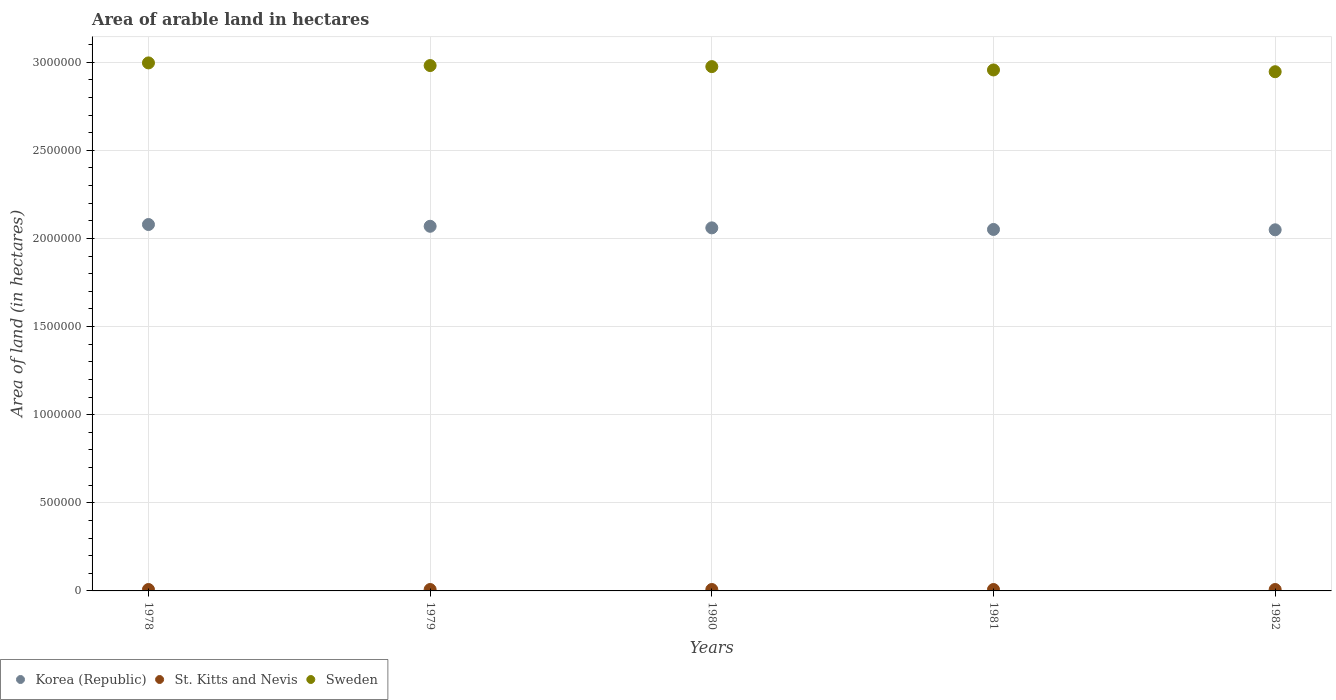What is the total arable land in Sweden in 1979?
Your response must be concise. 2.98e+06. Across all years, what is the maximum total arable land in St. Kitts and Nevis?
Your answer should be compact. 8000. Across all years, what is the minimum total arable land in Sweden?
Your response must be concise. 2.95e+06. In which year was the total arable land in Sweden maximum?
Ensure brevity in your answer.  1978. In which year was the total arable land in Korea (Republic) minimum?
Your answer should be compact. 1982. What is the total total arable land in St. Kitts and Nevis in the graph?
Provide a succinct answer. 4.00e+04. What is the difference between the total arable land in Korea (Republic) in 1978 and the total arable land in Sweden in 1980?
Provide a short and direct response. -8.96e+05. What is the average total arable land in Korea (Republic) per year?
Make the answer very short. 2.06e+06. In the year 1979, what is the difference between the total arable land in St. Kitts and Nevis and total arable land in Sweden?
Provide a short and direct response. -2.97e+06. In how many years, is the total arable land in Korea (Republic) greater than 2100000 hectares?
Keep it short and to the point. 0. Is the total arable land in St. Kitts and Nevis in 1981 less than that in 1982?
Your answer should be very brief. No. What is the difference between the highest and the second highest total arable land in Korea (Republic)?
Give a very brief answer. 10000. What is the difference between the highest and the lowest total arable land in Sweden?
Keep it short and to the point. 5.00e+04. In how many years, is the total arable land in Korea (Republic) greater than the average total arable land in Korea (Republic) taken over all years?
Your answer should be very brief. 2. Is it the case that in every year, the sum of the total arable land in Sweden and total arable land in Korea (Republic)  is greater than the total arable land in St. Kitts and Nevis?
Provide a short and direct response. Yes. How many dotlines are there?
Your answer should be very brief. 3. What is the difference between two consecutive major ticks on the Y-axis?
Offer a very short reply. 5.00e+05. Does the graph contain any zero values?
Give a very brief answer. No. How are the legend labels stacked?
Give a very brief answer. Horizontal. What is the title of the graph?
Provide a short and direct response. Area of arable land in hectares. What is the label or title of the Y-axis?
Make the answer very short. Area of land (in hectares). What is the Area of land (in hectares) of Korea (Republic) in 1978?
Ensure brevity in your answer.  2.08e+06. What is the Area of land (in hectares) in St. Kitts and Nevis in 1978?
Offer a terse response. 8000. What is the Area of land (in hectares) of Sweden in 1978?
Your answer should be compact. 3.00e+06. What is the Area of land (in hectares) of Korea (Republic) in 1979?
Provide a succinct answer. 2.07e+06. What is the Area of land (in hectares) of St. Kitts and Nevis in 1979?
Your answer should be compact. 8000. What is the Area of land (in hectares) of Sweden in 1979?
Keep it short and to the point. 2.98e+06. What is the Area of land (in hectares) of Korea (Republic) in 1980?
Provide a short and direct response. 2.06e+06. What is the Area of land (in hectares) of St. Kitts and Nevis in 1980?
Make the answer very short. 8000. What is the Area of land (in hectares) in Sweden in 1980?
Make the answer very short. 2.98e+06. What is the Area of land (in hectares) in Korea (Republic) in 1981?
Your response must be concise. 2.05e+06. What is the Area of land (in hectares) in St. Kitts and Nevis in 1981?
Offer a very short reply. 8000. What is the Area of land (in hectares) of Sweden in 1981?
Give a very brief answer. 2.96e+06. What is the Area of land (in hectares) of Korea (Republic) in 1982?
Your response must be concise. 2.05e+06. What is the Area of land (in hectares) in St. Kitts and Nevis in 1982?
Your answer should be very brief. 8000. What is the Area of land (in hectares) in Sweden in 1982?
Your answer should be very brief. 2.95e+06. Across all years, what is the maximum Area of land (in hectares) in Korea (Republic)?
Give a very brief answer. 2.08e+06. Across all years, what is the maximum Area of land (in hectares) of St. Kitts and Nevis?
Give a very brief answer. 8000. Across all years, what is the maximum Area of land (in hectares) in Sweden?
Provide a succinct answer. 3.00e+06. Across all years, what is the minimum Area of land (in hectares) in Korea (Republic)?
Provide a succinct answer. 2.05e+06. Across all years, what is the minimum Area of land (in hectares) of St. Kitts and Nevis?
Your answer should be compact. 8000. Across all years, what is the minimum Area of land (in hectares) in Sweden?
Offer a terse response. 2.95e+06. What is the total Area of land (in hectares) in Korea (Republic) in the graph?
Ensure brevity in your answer.  1.03e+07. What is the total Area of land (in hectares) in St. Kitts and Nevis in the graph?
Keep it short and to the point. 4.00e+04. What is the total Area of land (in hectares) of Sweden in the graph?
Keep it short and to the point. 1.49e+07. What is the difference between the Area of land (in hectares) in Sweden in 1978 and that in 1979?
Provide a short and direct response. 1.50e+04. What is the difference between the Area of land (in hectares) in Korea (Republic) in 1978 and that in 1980?
Offer a terse response. 1.90e+04. What is the difference between the Area of land (in hectares) in St. Kitts and Nevis in 1978 and that in 1980?
Ensure brevity in your answer.  0. What is the difference between the Area of land (in hectares) in Sweden in 1978 and that in 1980?
Ensure brevity in your answer.  2.10e+04. What is the difference between the Area of land (in hectares) in Korea (Republic) in 1978 and that in 1981?
Ensure brevity in your answer.  2.80e+04. What is the difference between the Area of land (in hectares) in Sweden in 1978 and that in 1981?
Provide a succinct answer. 4.00e+04. What is the difference between the Area of land (in hectares) in St. Kitts and Nevis in 1978 and that in 1982?
Keep it short and to the point. 0. What is the difference between the Area of land (in hectares) in Sweden in 1978 and that in 1982?
Provide a short and direct response. 5.00e+04. What is the difference between the Area of land (in hectares) in Korea (Republic) in 1979 and that in 1980?
Make the answer very short. 9000. What is the difference between the Area of land (in hectares) of Sweden in 1979 and that in 1980?
Offer a very short reply. 6000. What is the difference between the Area of land (in hectares) in Korea (Republic) in 1979 and that in 1981?
Your answer should be very brief. 1.80e+04. What is the difference between the Area of land (in hectares) in St. Kitts and Nevis in 1979 and that in 1981?
Provide a succinct answer. 0. What is the difference between the Area of land (in hectares) of Sweden in 1979 and that in 1981?
Make the answer very short. 2.50e+04. What is the difference between the Area of land (in hectares) in St. Kitts and Nevis in 1979 and that in 1982?
Ensure brevity in your answer.  0. What is the difference between the Area of land (in hectares) in Sweden in 1979 and that in 1982?
Offer a terse response. 3.50e+04. What is the difference between the Area of land (in hectares) in Korea (Republic) in 1980 and that in 1981?
Provide a succinct answer. 9000. What is the difference between the Area of land (in hectares) in St. Kitts and Nevis in 1980 and that in 1981?
Your response must be concise. 0. What is the difference between the Area of land (in hectares) of Sweden in 1980 and that in 1981?
Provide a succinct answer. 1.90e+04. What is the difference between the Area of land (in hectares) in Korea (Republic) in 1980 and that in 1982?
Your answer should be compact. 1.10e+04. What is the difference between the Area of land (in hectares) of St. Kitts and Nevis in 1980 and that in 1982?
Your response must be concise. 0. What is the difference between the Area of land (in hectares) of Sweden in 1980 and that in 1982?
Your answer should be very brief. 2.90e+04. What is the difference between the Area of land (in hectares) in Korea (Republic) in 1981 and that in 1982?
Keep it short and to the point. 2000. What is the difference between the Area of land (in hectares) of St. Kitts and Nevis in 1981 and that in 1982?
Your answer should be compact. 0. What is the difference between the Area of land (in hectares) in Korea (Republic) in 1978 and the Area of land (in hectares) in St. Kitts and Nevis in 1979?
Ensure brevity in your answer.  2.07e+06. What is the difference between the Area of land (in hectares) in Korea (Republic) in 1978 and the Area of land (in hectares) in Sweden in 1979?
Offer a terse response. -9.02e+05. What is the difference between the Area of land (in hectares) of St. Kitts and Nevis in 1978 and the Area of land (in hectares) of Sweden in 1979?
Keep it short and to the point. -2.97e+06. What is the difference between the Area of land (in hectares) in Korea (Republic) in 1978 and the Area of land (in hectares) in St. Kitts and Nevis in 1980?
Keep it short and to the point. 2.07e+06. What is the difference between the Area of land (in hectares) in Korea (Republic) in 1978 and the Area of land (in hectares) in Sweden in 1980?
Your response must be concise. -8.96e+05. What is the difference between the Area of land (in hectares) of St. Kitts and Nevis in 1978 and the Area of land (in hectares) of Sweden in 1980?
Provide a succinct answer. -2.97e+06. What is the difference between the Area of land (in hectares) in Korea (Republic) in 1978 and the Area of land (in hectares) in St. Kitts and Nevis in 1981?
Your answer should be very brief. 2.07e+06. What is the difference between the Area of land (in hectares) in Korea (Republic) in 1978 and the Area of land (in hectares) in Sweden in 1981?
Keep it short and to the point. -8.77e+05. What is the difference between the Area of land (in hectares) in St. Kitts and Nevis in 1978 and the Area of land (in hectares) in Sweden in 1981?
Offer a terse response. -2.95e+06. What is the difference between the Area of land (in hectares) in Korea (Republic) in 1978 and the Area of land (in hectares) in St. Kitts and Nevis in 1982?
Keep it short and to the point. 2.07e+06. What is the difference between the Area of land (in hectares) in Korea (Republic) in 1978 and the Area of land (in hectares) in Sweden in 1982?
Your answer should be compact. -8.67e+05. What is the difference between the Area of land (in hectares) in St. Kitts and Nevis in 1978 and the Area of land (in hectares) in Sweden in 1982?
Keep it short and to the point. -2.94e+06. What is the difference between the Area of land (in hectares) of Korea (Republic) in 1979 and the Area of land (in hectares) of St. Kitts and Nevis in 1980?
Make the answer very short. 2.06e+06. What is the difference between the Area of land (in hectares) in Korea (Republic) in 1979 and the Area of land (in hectares) in Sweden in 1980?
Offer a very short reply. -9.06e+05. What is the difference between the Area of land (in hectares) of St. Kitts and Nevis in 1979 and the Area of land (in hectares) of Sweden in 1980?
Provide a succinct answer. -2.97e+06. What is the difference between the Area of land (in hectares) in Korea (Republic) in 1979 and the Area of land (in hectares) in St. Kitts and Nevis in 1981?
Ensure brevity in your answer.  2.06e+06. What is the difference between the Area of land (in hectares) of Korea (Republic) in 1979 and the Area of land (in hectares) of Sweden in 1981?
Provide a succinct answer. -8.87e+05. What is the difference between the Area of land (in hectares) of St. Kitts and Nevis in 1979 and the Area of land (in hectares) of Sweden in 1981?
Make the answer very short. -2.95e+06. What is the difference between the Area of land (in hectares) of Korea (Republic) in 1979 and the Area of land (in hectares) of St. Kitts and Nevis in 1982?
Provide a short and direct response. 2.06e+06. What is the difference between the Area of land (in hectares) of Korea (Republic) in 1979 and the Area of land (in hectares) of Sweden in 1982?
Offer a very short reply. -8.77e+05. What is the difference between the Area of land (in hectares) in St. Kitts and Nevis in 1979 and the Area of land (in hectares) in Sweden in 1982?
Give a very brief answer. -2.94e+06. What is the difference between the Area of land (in hectares) in Korea (Republic) in 1980 and the Area of land (in hectares) in St. Kitts and Nevis in 1981?
Your answer should be compact. 2.05e+06. What is the difference between the Area of land (in hectares) in Korea (Republic) in 1980 and the Area of land (in hectares) in Sweden in 1981?
Give a very brief answer. -8.96e+05. What is the difference between the Area of land (in hectares) in St. Kitts and Nevis in 1980 and the Area of land (in hectares) in Sweden in 1981?
Give a very brief answer. -2.95e+06. What is the difference between the Area of land (in hectares) in Korea (Republic) in 1980 and the Area of land (in hectares) in St. Kitts and Nevis in 1982?
Make the answer very short. 2.05e+06. What is the difference between the Area of land (in hectares) of Korea (Republic) in 1980 and the Area of land (in hectares) of Sweden in 1982?
Give a very brief answer. -8.86e+05. What is the difference between the Area of land (in hectares) in St. Kitts and Nevis in 1980 and the Area of land (in hectares) in Sweden in 1982?
Offer a terse response. -2.94e+06. What is the difference between the Area of land (in hectares) in Korea (Republic) in 1981 and the Area of land (in hectares) in St. Kitts and Nevis in 1982?
Your answer should be very brief. 2.04e+06. What is the difference between the Area of land (in hectares) of Korea (Republic) in 1981 and the Area of land (in hectares) of Sweden in 1982?
Your answer should be very brief. -8.95e+05. What is the difference between the Area of land (in hectares) in St. Kitts and Nevis in 1981 and the Area of land (in hectares) in Sweden in 1982?
Your answer should be very brief. -2.94e+06. What is the average Area of land (in hectares) of Korea (Republic) per year?
Your answer should be compact. 2.06e+06. What is the average Area of land (in hectares) of St. Kitts and Nevis per year?
Give a very brief answer. 8000. What is the average Area of land (in hectares) of Sweden per year?
Give a very brief answer. 2.97e+06. In the year 1978, what is the difference between the Area of land (in hectares) of Korea (Republic) and Area of land (in hectares) of St. Kitts and Nevis?
Provide a short and direct response. 2.07e+06. In the year 1978, what is the difference between the Area of land (in hectares) of Korea (Republic) and Area of land (in hectares) of Sweden?
Your answer should be compact. -9.17e+05. In the year 1978, what is the difference between the Area of land (in hectares) of St. Kitts and Nevis and Area of land (in hectares) of Sweden?
Your answer should be very brief. -2.99e+06. In the year 1979, what is the difference between the Area of land (in hectares) of Korea (Republic) and Area of land (in hectares) of St. Kitts and Nevis?
Give a very brief answer. 2.06e+06. In the year 1979, what is the difference between the Area of land (in hectares) of Korea (Republic) and Area of land (in hectares) of Sweden?
Provide a succinct answer. -9.12e+05. In the year 1979, what is the difference between the Area of land (in hectares) in St. Kitts and Nevis and Area of land (in hectares) in Sweden?
Keep it short and to the point. -2.97e+06. In the year 1980, what is the difference between the Area of land (in hectares) in Korea (Republic) and Area of land (in hectares) in St. Kitts and Nevis?
Your response must be concise. 2.05e+06. In the year 1980, what is the difference between the Area of land (in hectares) of Korea (Republic) and Area of land (in hectares) of Sweden?
Your response must be concise. -9.15e+05. In the year 1980, what is the difference between the Area of land (in hectares) in St. Kitts and Nevis and Area of land (in hectares) in Sweden?
Provide a short and direct response. -2.97e+06. In the year 1981, what is the difference between the Area of land (in hectares) of Korea (Republic) and Area of land (in hectares) of St. Kitts and Nevis?
Make the answer very short. 2.04e+06. In the year 1981, what is the difference between the Area of land (in hectares) of Korea (Republic) and Area of land (in hectares) of Sweden?
Give a very brief answer. -9.05e+05. In the year 1981, what is the difference between the Area of land (in hectares) of St. Kitts and Nevis and Area of land (in hectares) of Sweden?
Your response must be concise. -2.95e+06. In the year 1982, what is the difference between the Area of land (in hectares) in Korea (Republic) and Area of land (in hectares) in St. Kitts and Nevis?
Give a very brief answer. 2.04e+06. In the year 1982, what is the difference between the Area of land (in hectares) of Korea (Republic) and Area of land (in hectares) of Sweden?
Keep it short and to the point. -8.97e+05. In the year 1982, what is the difference between the Area of land (in hectares) of St. Kitts and Nevis and Area of land (in hectares) of Sweden?
Your answer should be very brief. -2.94e+06. What is the ratio of the Area of land (in hectares) of St. Kitts and Nevis in 1978 to that in 1979?
Ensure brevity in your answer.  1. What is the ratio of the Area of land (in hectares) in Sweden in 1978 to that in 1979?
Give a very brief answer. 1. What is the ratio of the Area of land (in hectares) of Korea (Republic) in 1978 to that in 1980?
Your answer should be very brief. 1.01. What is the ratio of the Area of land (in hectares) in Sweden in 1978 to that in 1980?
Provide a short and direct response. 1.01. What is the ratio of the Area of land (in hectares) of Korea (Republic) in 1978 to that in 1981?
Offer a very short reply. 1.01. What is the ratio of the Area of land (in hectares) of Sweden in 1978 to that in 1981?
Give a very brief answer. 1.01. What is the ratio of the Area of land (in hectares) in Korea (Republic) in 1978 to that in 1982?
Provide a succinct answer. 1.01. What is the ratio of the Area of land (in hectares) of Sweden in 1978 to that in 1982?
Provide a short and direct response. 1.02. What is the ratio of the Area of land (in hectares) in Korea (Republic) in 1979 to that in 1980?
Provide a short and direct response. 1. What is the ratio of the Area of land (in hectares) in St. Kitts and Nevis in 1979 to that in 1980?
Make the answer very short. 1. What is the ratio of the Area of land (in hectares) in Korea (Republic) in 1979 to that in 1981?
Your answer should be compact. 1.01. What is the ratio of the Area of land (in hectares) of Sweden in 1979 to that in 1981?
Make the answer very short. 1.01. What is the ratio of the Area of land (in hectares) of Korea (Republic) in 1979 to that in 1982?
Ensure brevity in your answer.  1.01. What is the ratio of the Area of land (in hectares) in Sweden in 1979 to that in 1982?
Give a very brief answer. 1.01. What is the ratio of the Area of land (in hectares) in Korea (Republic) in 1980 to that in 1981?
Give a very brief answer. 1. What is the ratio of the Area of land (in hectares) of St. Kitts and Nevis in 1980 to that in 1981?
Offer a terse response. 1. What is the ratio of the Area of land (in hectares) of Sweden in 1980 to that in 1981?
Offer a terse response. 1.01. What is the ratio of the Area of land (in hectares) in Korea (Republic) in 1980 to that in 1982?
Your answer should be very brief. 1.01. What is the ratio of the Area of land (in hectares) of Sweden in 1980 to that in 1982?
Your answer should be compact. 1.01. What is the ratio of the Area of land (in hectares) of Sweden in 1981 to that in 1982?
Make the answer very short. 1. What is the difference between the highest and the second highest Area of land (in hectares) of Korea (Republic)?
Your answer should be very brief. 10000. What is the difference between the highest and the second highest Area of land (in hectares) of Sweden?
Make the answer very short. 1.50e+04. What is the difference between the highest and the lowest Area of land (in hectares) in St. Kitts and Nevis?
Offer a very short reply. 0. What is the difference between the highest and the lowest Area of land (in hectares) of Sweden?
Give a very brief answer. 5.00e+04. 